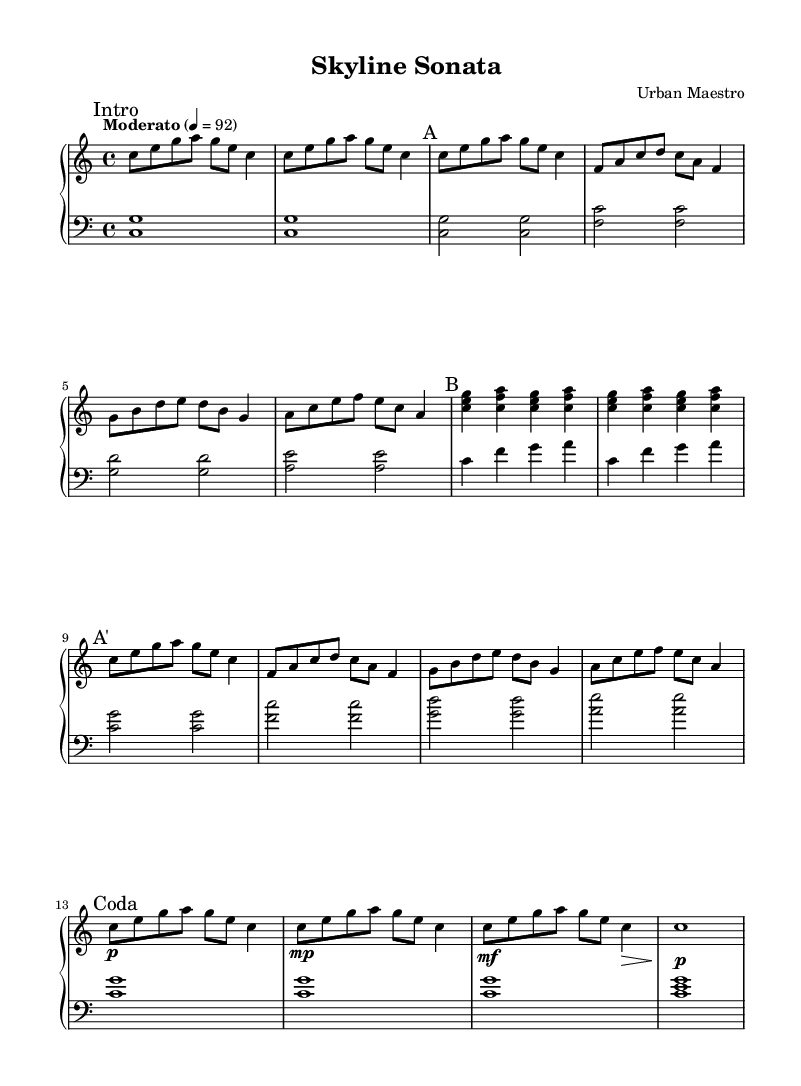What is the key signature of this music? The key signature is C major, which has no sharps or flats.
Answer: C major What is the time signature of this piece? The time signature indicates how many beats are in each measure, which is shown as 4/4.
Answer: 4/4 What is the tempo marking for this composition? The tempo marking is indicated at the beginning of the sheet music, which is "Moderato" set to 92 beats per minute.
Answer: Moderato How many distinct sections are identified in this piece? The piece is divided into sections labeled as "Intro," "A," "B," "A'," and "Coda," totaling five sections.
Answer: Five In section B, how many measures are present? Section B consists of four measures where clashing chords are played, each measure is demarcated by the vertical lines.
Answer: Four What dynamic marking appears before the last measure? The last measure has a dynamic marking of "p" indicating it should be played softly.
Answer: p What is the melodic contour in section A'? Section A' follows the same melodic pattern as section A, providing thematic coherence while slightly varying the dynamics across the measures.
Answer: Similar 